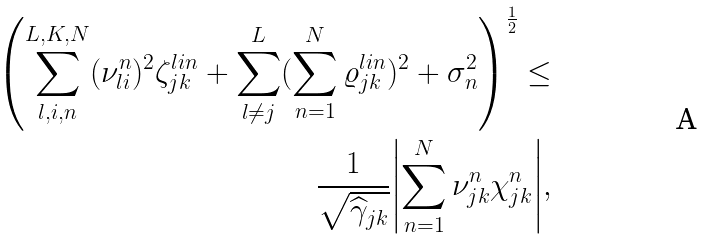<formula> <loc_0><loc_0><loc_500><loc_500>\left ( \sum _ { l , i , n } ^ { L , K , N } ( \nu _ { l i } ^ { n } ) ^ { 2 } \zeta _ { j k } ^ { l i n } + \sum _ { l \neq j } ^ { L } ( \sum _ { n = 1 } ^ { N } \varrho _ { j k } ^ { l i n } ) ^ { 2 } + \sigma _ { n } ^ { 2 } \right ) ^ { \frac { 1 } { 2 } } \leq \\ \frac { 1 } { \sqrt { \widehat { \gamma } _ { j k } } } { \left | \sum _ { n = 1 } ^ { N } \nu _ { j k } ^ { n } \chi _ { j k } ^ { n } \right | } ,</formula> 